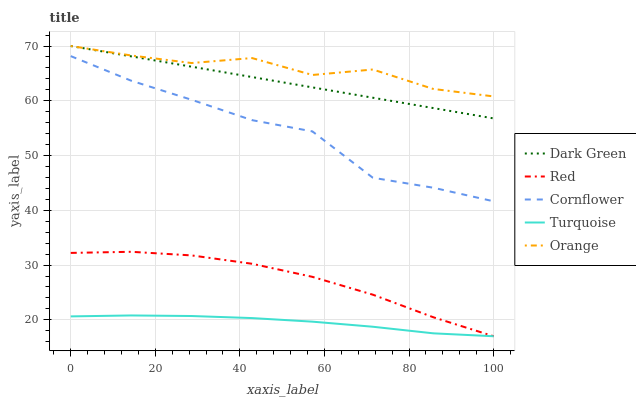Does Turquoise have the minimum area under the curve?
Answer yes or no. Yes. Does Orange have the maximum area under the curve?
Answer yes or no. Yes. Does Cornflower have the minimum area under the curve?
Answer yes or no. No. Does Cornflower have the maximum area under the curve?
Answer yes or no. No. Is Dark Green the smoothest?
Answer yes or no. Yes. Is Orange the roughest?
Answer yes or no. Yes. Is Cornflower the smoothest?
Answer yes or no. No. Is Cornflower the roughest?
Answer yes or no. No. Does Cornflower have the lowest value?
Answer yes or no. No. Does Cornflower have the highest value?
Answer yes or no. No. Is Turquoise less than Dark Green?
Answer yes or no. Yes. Is Cornflower greater than Turquoise?
Answer yes or no. Yes. Does Turquoise intersect Dark Green?
Answer yes or no. No. 